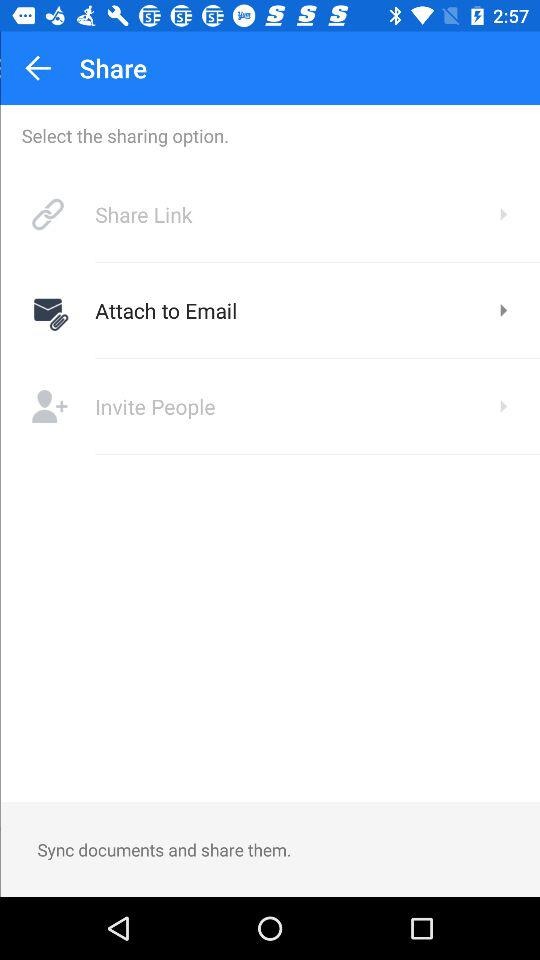How many sharing options are available?
Answer the question using a single word or phrase. 3 